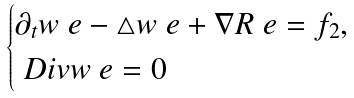<formula> <loc_0><loc_0><loc_500><loc_500>\begin{cases} \partial _ { t } w _ { \ } e - \triangle w _ { \ } e + \nabla R _ { \ } e = f _ { 2 } , \\ \ D i v w _ { \ } e = 0 \end{cases}</formula> 